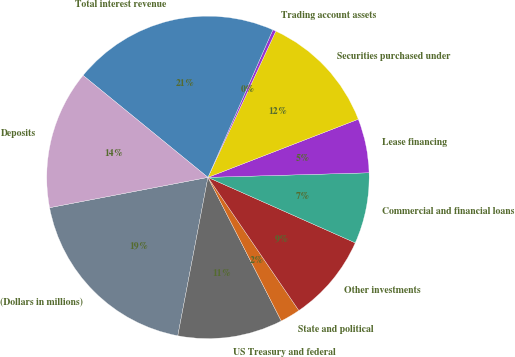<chart> <loc_0><loc_0><loc_500><loc_500><pie_chart><fcel>(Dollars in millions)<fcel>US Treasury and federal<fcel>State and political<fcel>Other investments<fcel>Commercial and financial loans<fcel>Lease financing<fcel>Securities purchased under<fcel>Trading account assets<fcel>Total interest revenue<fcel>Deposits<nl><fcel>19.0%<fcel>10.51%<fcel>2.02%<fcel>8.81%<fcel>7.11%<fcel>5.42%<fcel>12.21%<fcel>0.32%<fcel>20.7%<fcel>13.91%<nl></chart> 